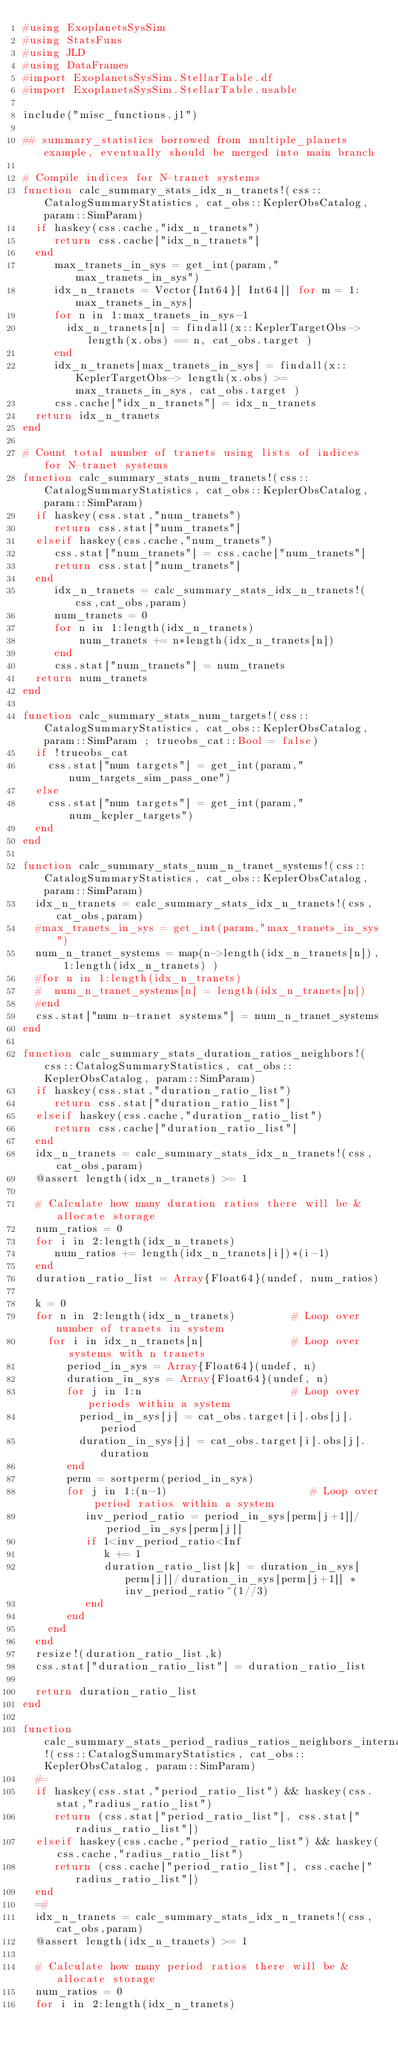<code> <loc_0><loc_0><loc_500><loc_500><_Julia_>#using ExoplanetsSysSim
#using StatsFuns
#using JLD
#using DataFrames
#import ExoplanetsSysSim.StellarTable.df
#import ExoplanetsSysSim.StellarTable.usable

include("misc_functions.jl")

## summary_statistics borrowed from multiple_planets example, eventually should be merged into main branch

# Compile indices for N-tranet systems
function calc_summary_stats_idx_n_tranets!(css::CatalogSummaryStatistics, cat_obs::KeplerObsCatalog, param::SimParam)
  if haskey(css.cache,"idx_n_tranets")
     return css.cache["idx_n_tranets"]
  end
     max_tranets_in_sys = get_int(param,"max_tranets_in_sys")    
     idx_n_tranets = Vector{Int64}[ Int64[] for m = 1:max_tranets_in_sys]
     for n in 1:max_tranets_in_sys-1
       idx_n_tranets[n] = findall(x::KeplerTargetObs-> length(x.obs) == n, cat_obs.target )
     end
     idx_n_tranets[max_tranets_in_sys] = findall(x::KeplerTargetObs-> length(x.obs) >= max_tranets_in_sys, cat_obs.target )
     css.cache["idx_n_tranets"] = idx_n_tranets
  return idx_n_tranets 
end

# Count total number of tranets using lists of indices for N-tranet systems
function calc_summary_stats_num_tranets!(css::CatalogSummaryStatistics, cat_obs::KeplerObsCatalog, param::SimParam)
  if haskey(css.stat,"num_tranets")
     return css.stat["num_tranets"]
  elseif haskey(css.cache,"num_tranets")
     css.stat["num_tranets"] = css.cache["num_tranets"]
     return css.stat["num_tranets"]
  end
     idx_n_tranets = calc_summary_stats_idx_n_tranets!(css,cat_obs,param)
     num_tranets = 0
     for n in 1:length(idx_n_tranets)
         num_tranets += n*length(idx_n_tranets[n])
     end
     css.stat["num_tranets"] = num_tranets
  return num_tranets 
end

function calc_summary_stats_num_targets!(css::CatalogSummaryStatistics, cat_obs::KeplerObsCatalog, param::SimParam ; trueobs_cat::Bool = false)
  if !trueobs_cat
    css.stat["num targets"] = get_int(param,"num_targets_sim_pass_one")
  else
    css.stat["num targets"] = get_int(param,"num_kepler_targets")
  end
end

function calc_summary_stats_num_n_tranet_systems!(css::CatalogSummaryStatistics, cat_obs::KeplerObsCatalog, param::SimParam)
  idx_n_tranets = calc_summary_stats_idx_n_tranets!(css,cat_obs,param)
  #max_tranets_in_sys = get_int(param,"max_tranets_in_sys")    
  num_n_tranet_systems = map(n->length(idx_n_tranets[n]), 1:length(idx_n_tranets) )
  #for n in 1:length(idx_n_tranets)
  #  num_n_tranet_systems[n] = length(idx_n_tranets[n])
  #end
  css.stat["num n-tranet systems"] = num_n_tranet_systems
end

function calc_summary_stats_duration_ratios_neighbors!(css::CatalogSummaryStatistics, cat_obs::KeplerObsCatalog, param::SimParam)
  if haskey(css.stat,"duration_ratio_list")
     return css.stat["duration_ratio_list"]
  elseif haskey(css.cache,"duration_ratio_list")
     return css.cache["duration_ratio_list"]
  end
  idx_n_tranets = calc_summary_stats_idx_n_tranets!(css,cat_obs,param)
  @assert length(idx_n_tranets) >= 1 

  # Calculate how many duration ratios there will be & allocate storage
  num_ratios = 0
  for i in 2:length(idx_n_tranets)
     num_ratios += length(idx_n_tranets[i])*(i-1)
  end
  duration_ratio_list = Array{Float64}(undef, num_ratios)
 
  k = 0
  for n in 2:length(idx_n_tranets)         # Loop over number of tranets in system
    for i in idx_n_tranets[n]              # Loop over systems with n tranets
       period_in_sys = Array{Float64}(undef, n)
       duration_in_sys = Array{Float64}(undef, n)
       for j in 1:n                        # Loop over periods within a system
         period_in_sys[j] = cat_obs.target[i].obs[j].period
         duration_in_sys[j] = cat_obs.target[i].obs[j].duration
       end
       perm = sortperm(period_in_sys)
       for j in 1:(n-1)                       # Loop over period ratios within a system
          inv_period_ratio = period_in_sys[perm[j+1]]/period_in_sys[perm[j]]
          if 1<inv_period_ratio<Inf
             k += 1
             duration_ratio_list[k] = duration_in_sys[perm[j]]/duration_in_sys[perm[j+1]] * inv_period_ratio^(1//3)
          end
       end
    end
  end
  resize!(duration_ratio_list,k)
  css.stat["duration_ratio_list"] = duration_ratio_list

  return duration_ratio_list
end

function calc_summary_stats_period_radius_ratios_neighbors_internal!(css::CatalogSummaryStatistics, cat_obs::KeplerObsCatalog, param::SimParam)
  #=
  if haskey(css.stat,"period_ratio_list") && haskey(css.stat,"radius_ratio_list")
     return (css.stat["period_ratio_list"], css.stat["radius_ratio_list"])
  elseif haskey(css.cache,"period_ratio_list") && haskey(css.cache,"radius_ratio_list")
     return (css.cache["period_ratio_list"], css.cache["radius_ratio_list"])
  end
  =#
  idx_n_tranets = calc_summary_stats_idx_n_tranets!(css,cat_obs,param)
  @assert length(idx_n_tranets) >= 1 

  # Calculate how many period ratios there will be & allocate storage
  num_ratios = 0
  for i in 2:length(idx_n_tranets)</code> 